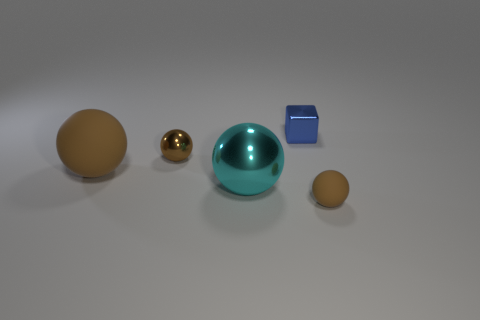Are there more balls behind the tiny blue thing than tiny cubes on the left side of the big brown thing? No, there are not more balls behind the tiny blue cube; there are just two balls visible. As for the tiny cubes on the left side of the big brown thing, there is only one visible. So, the number of balls behind the blue cube does not exceed the number of cubes. 